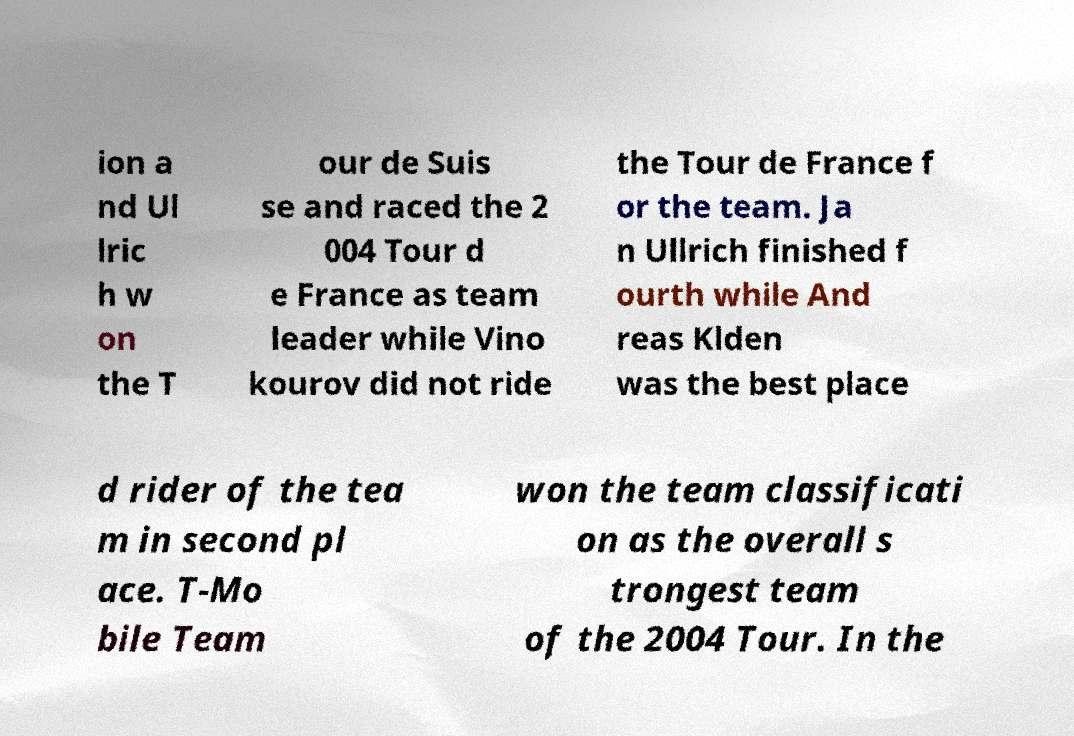Could you extract and type out the text from this image? ion a nd Ul lric h w on the T our de Suis se and raced the 2 004 Tour d e France as team leader while Vino kourov did not ride the Tour de France f or the team. Ja n Ullrich finished f ourth while And reas Klden was the best place d rider of the tea m in second pl ace. T-Mo bile Team won the team classificati on as the overall s trongest team of the 2004 Tour. In the 